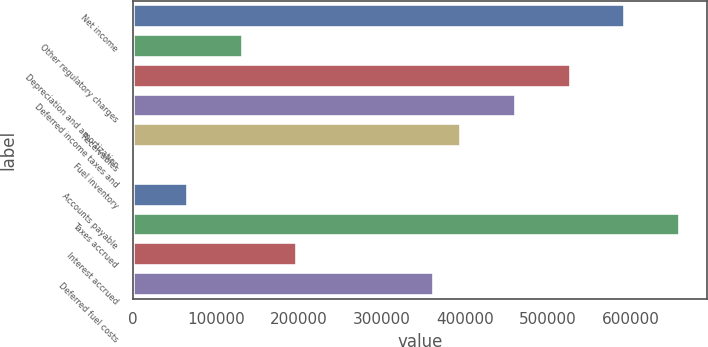Convert chart. <chart><loc_0><loc_0><loc_500><loc_500><bar_chart><fcel>Net income<fcel>Other regulatory charges<fcel>Depreciation and amortization<fcel>Deferred income taxes and<fcel>Receivables<fcel>Fuel inventory<fcel>Accounts payable<fcel>Taxes accrued<fcel>Interest accrued<fcel>Deferred fuel costs<nl><fcel>593540<fcel>132345<fcel>527655<fcel>461770<fcel>395885<fcel>575<fcel>66460<fcel>659425<fcel>198230<fcel>362942<nl></chart> 